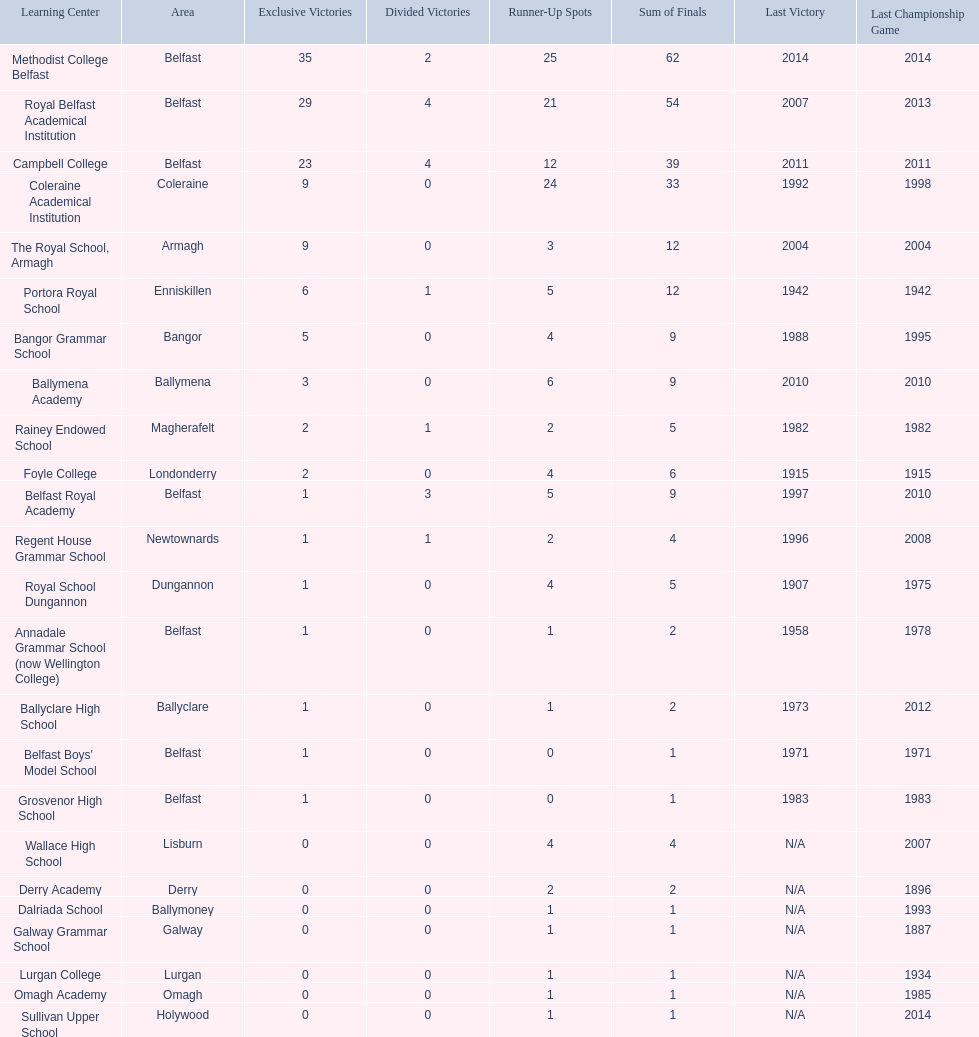Could you help me parse every detail presented in this table? {'header': ['Learning Center', 'Area', 'Exclusive Victories', 'Divided Victories', 'Runner-Up Spots', 'Sum of Finals', 'Last Victory', 'Last Championship Game'], 'rows': [['Methodist College Belfast', 'Belfast', '35', '2', '25', '62', '2014', '2014'], ['Royal Belfast Academical Institution', 'Belfast', '29', '4', '21', '54', '2007', '2013'], ['Campbell College', 'Belfast', '23', '4', '12', '39', '2011', '2011'], ['Coleraine Academical Institution', 'Coleraine', '9', '0', '24', '33', '1992', '1998'], ['The Royal School, Armagh', 'Armagh', '9', '0', '3', '12', '2004', '2004'], ['Portora Royal School', 'Enniskillen', '6', '1', '5', '12', '1942', '1942'], ['Bangor Grammar School', 'Bangor', '5', '0', '4', '9', '1988', '1995'], ['Ballymena Academy', 'Ballymena', '3', '0', '6', '9', '2010', '2010'], ['Rainey Endowed School', 'Magherafelt', '2', '1', '2', '5', '1982', '1982'], ['Foyle College', 'Londonderry', '2', '0', '4', '6', '1915', '1915'], ['Belfast Royal Academy', 'Belfast', '1', '3', '5', '9', '1997', '2010'], ['Regent House Grammar School', 'Newtownards', '1', '1', '2', '4', '1996', '2008'], ['Royal School Dungannon', 'Dungannon', '1', '0', '4', '5', '1907', '1975'], ['Annadale Grammar School (now Wellington College)', 'Belfast', '1', '0', '1', '2', '1958', '1978'], ['Ballyclare High School', 'Ballyclare', '1', '0', '1', '2', '1973', '2012'], ["Belfast Boys' Model School", 'Belfast', '1', '0', '0', '1', '1971', '1971'], ['Grosvenor High School', 'Belfast', '1', '0', '0', '1', '1983', '1983'], ['Wallace High School', 'Lisburn', '0', '0', '4', '4', 'N/A', '2007'], ['Derry Academy', 'Derry', '0', '0', '2', '2', 'N/A', '1896'], ['Dalriada School', 'Ballymoney', '0', '0', '1', '1', 'N/A', '1993'], ['Galway Grammar School', 'Galway', '0', '0', '1', '1', 'N/A', '1887'], ['Lurgan College', 'Lurgan', '0', '0', '1', '1', 'N/A', '1934'], ['Omagh Academy', 'Omagh', '0', '0', '1', '1', 'N/A', '1985'], ['Sullivan Upper School', 'Holywood', '0', '0', '1', '1', 'N/A', '2014']]} Who has the most recent title win, campbell college or regent house grammar school? Campbell College. 